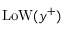Convert formula to latex. <formula><loc_0><loc_0><loc_500><loc_500>L o W ( y ^ { + } )</formula> 